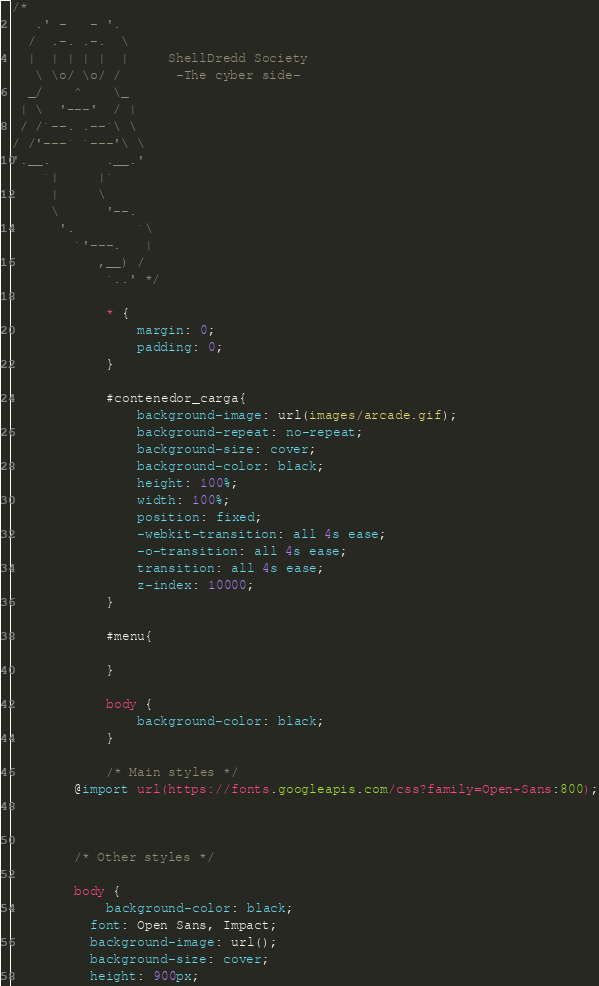<code> <loc_0><loc_0><loc_500><loc_500><_CSS_>/* 
   .' -   - '.
  /  .-. .-.  \
  |  | | | |  |     ShellDredd Society
   \ \o/ \o/ /       -The cyber side-
  _/    ^    \_
 | \  '---'  / |
 / /`--. .--`\ \
/ /'---` `---'\ \
'.__.       .__.'
    `|     |`
     |     \
     \      '--.
      '.        `\
        `'---.   |
           ,__) /
            `..' */

            * {
                margin: 0;
                padding: 0;
            }
            
            #contenedor_carga{
                background-image: url(images/arcade.gif);
                background-repeat: no-repeat;
                background-size: cover;
                background-color: black;
                height: 100%;
                width: 100%;
                position: fixed;
                -webkit-transition: all 4s ease;
                -o-transition: all 4s ease;
                transition: all 4s ease;
                z-index: 10000;
            }
            
            #menu{
                
            }

            body {
                background-color: black;
            }
        
            /* Main styles */
        @import url(https://fonts.googleapis.com/css?family=Open+Sans:800);
        
      
        
        /* Other styles */
        
        body {
            background-color: black;
          font: Open Sans, Impact;
          background-image: url();
          background-size: cover;
          height: 900px;</code> 